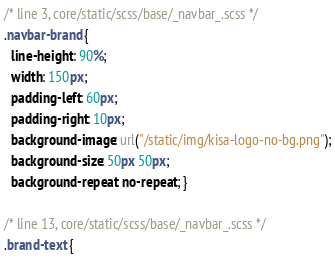<code> <loc_0><loc_0><loc_500><loc_500><_CSS_>/* line 3, core/static/scss/base/_navbar_.scss */
.navbar-brand {
  line-height: 90%;
  width: 150px;
  padding-left: 60px;
  padding-right: 10px;
  background-image: url("/static/img/kisa-logo-no-bg.png");
  background-size: 50px 50px;
  background-repeat: no-repeat; }

/* line 13, core/static/scss/base/_navbar_.scss */
.brand-text {</code> 